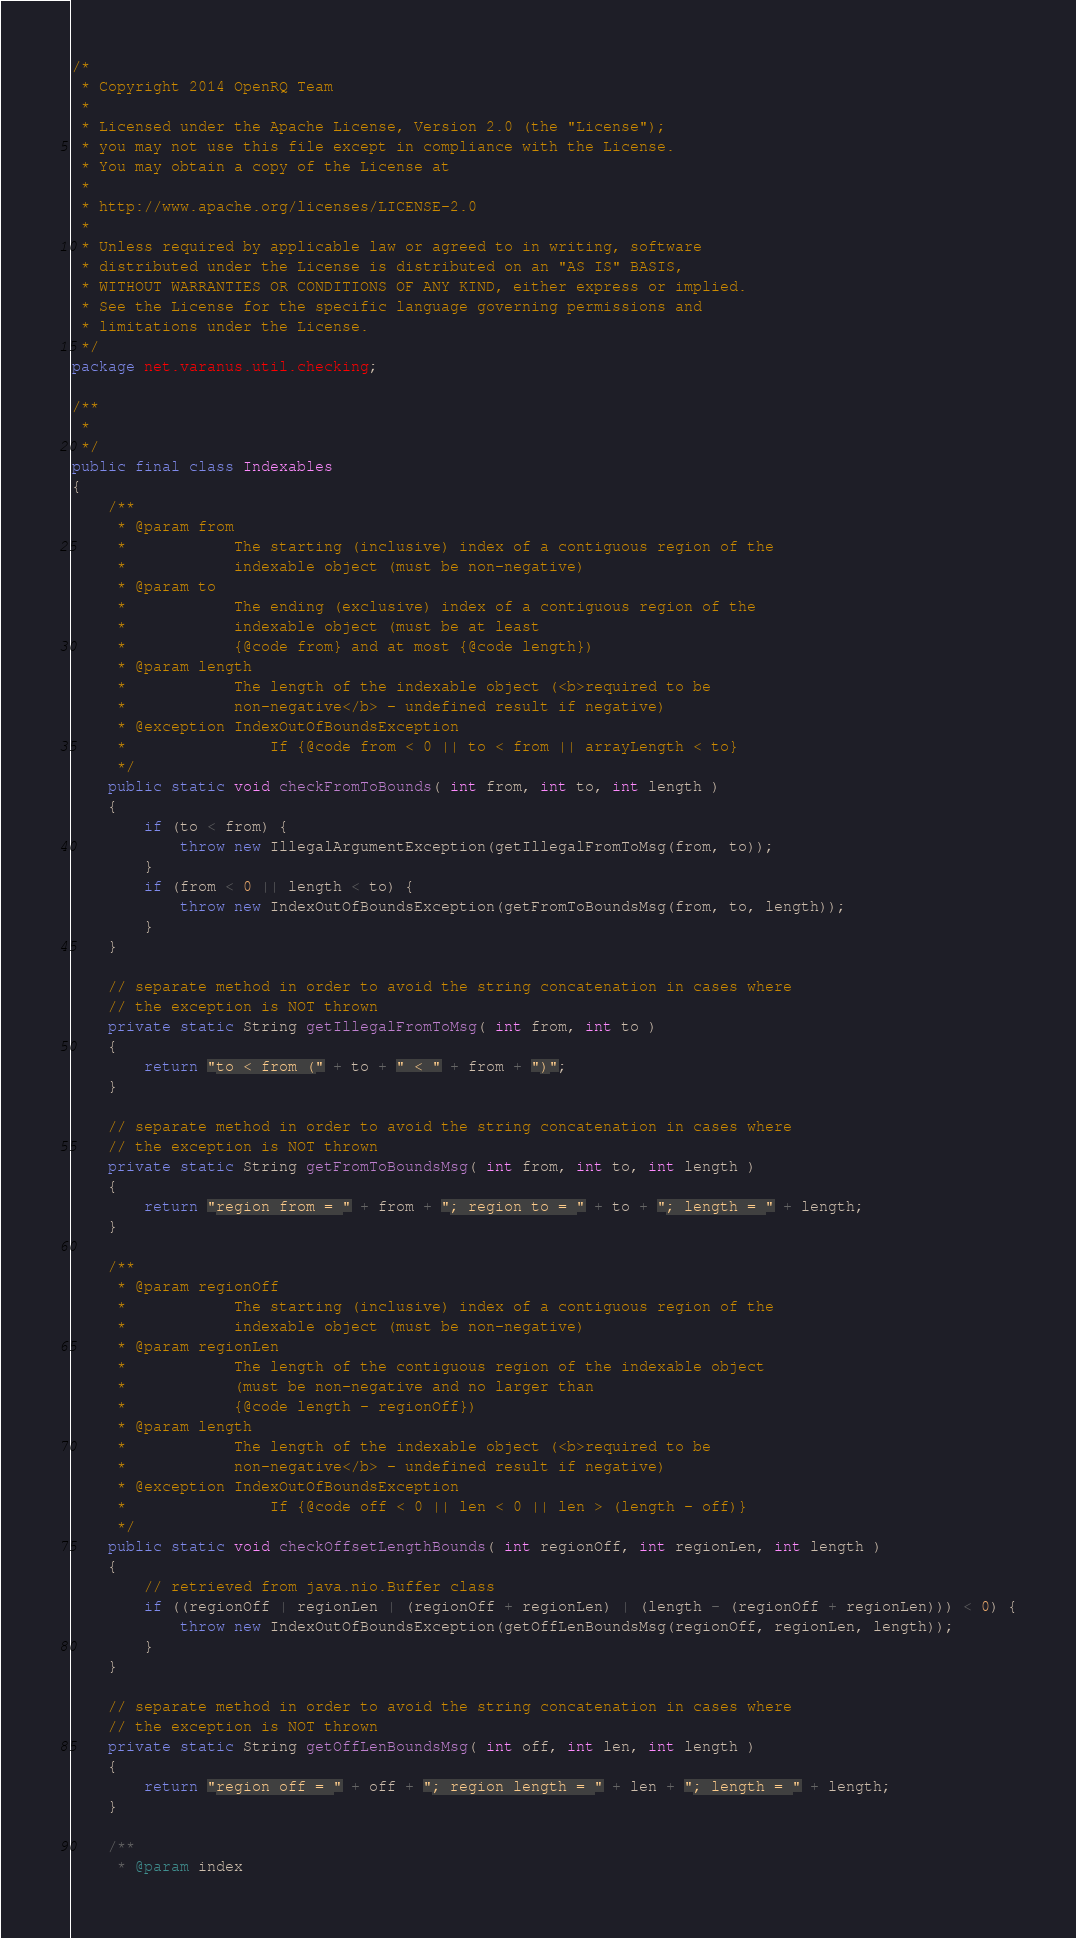Convert code to text. <code><loc_0><loc_0><loc_500><loc_500><_Java_>/*
 * Copyright 2014 OpenRQ Team
 * 
 * Licensed under the Apache License, Version 2.0 (the "License");
 * you may not use this file except in compliance with the License.
 * You may obtain a copy of the License at
 * 
 * http://www.apache.org/licenses/LICENSE-2.0
 * 
 * Unless required by applicable law or agreed to in writing, software
 * distributed under the License is distributed on an "AS IS" BASIS,
 * WITHOUT WARRANTIES OR CONDITIONS OF ANY KIND, either express or implied.
 * See the License for the specific language governing permissions and
 * limitations under the License.
 */
package net.varanus.util.checking;

/**
 * 
 */
public final class Indexables
{
    /**
     * @param from
     *            The starting (inclusive) index of a contiguous region of the
     *            indexable object (must be non-negative)
     * @param to
     *            The ending (exclusive) index of a contiguous region of the
     *            indexable object (must be at least
     *            {@code from} and at most {@code length})
     * @param length
     *            The length of the indexable object (<b>required to be
     *            non-negative</b> - undefined result if negative)
     * @exception IndexOutOfBoundsException
     *                If {@code from < 0 || to < from || arrayLength < to}
     */
    public static void checkFromToBounds( int from, int to, int length )
    {
        if (to < from) {
            throw new IllegalArgumentException(getIllegalFromToMsg(from, to));
        }
        if (from < 0 || length < to) {
            throw new IndexOutOfBoundsException(getFromToBoundsMsg(from, to, length));
        }
    }

    // separate method in order to avoid the string concatenation in cases where
    // the exception is NOT thrown
    private static String getIllegalFromToMsg( int from, int to )
    {
        return "to < from (" + to + " < " + from + ")";
    }

    // separate method in order to avoid the string concatenation in cases where
    // the exception is NOT thrown
    private static String getFromToBoundsMsg( int from, int to, int length )
    {
        return "region from = " + from + "; region to = " + to + "; length = " + length;
    }

    /**
     * @param regionOff
     *            The starting (inclusive) index of a contiguous region of the
     *            indexable object (must be non-negative)
     * @param regionLen
     *            The length of the contiguous region of the indexable object
     *            (must be non-negative and no larger than
     *            {@code length - regionOff})
     * @param length
     *            The length of the indexable object (<b>required to be
     *            non-negative</b> - undefined result if negative)
     * @exception IndexOutOfBoundsException
     *                If {@code off < 0 || len < 0 || len > (length - off)}
     */
    public static void checkOffsetLengthBounds( int regionOff, int regionLen, int length )
    {
        // retrieved from java.nio.Buffer class
        if ((regionOff | regionLen | (regionOff + regionLen) | (length - (regionOff + regionLen))) < 0) {
            throw new IndexOutOfBoundsException(getOffLenBoundsMsg(regionOff, regionLen, length));
        }
    }

    // separate method in order to avoid the string concatenation in cases where
    // the exception is NOT thrown
    private static String getOffLenBoundsMsg( int off, int len, int length )
    {
        return "region off = " + off + "; region length = " + len + "; length = " + length;
    }

    /**
     * @param index</code> 